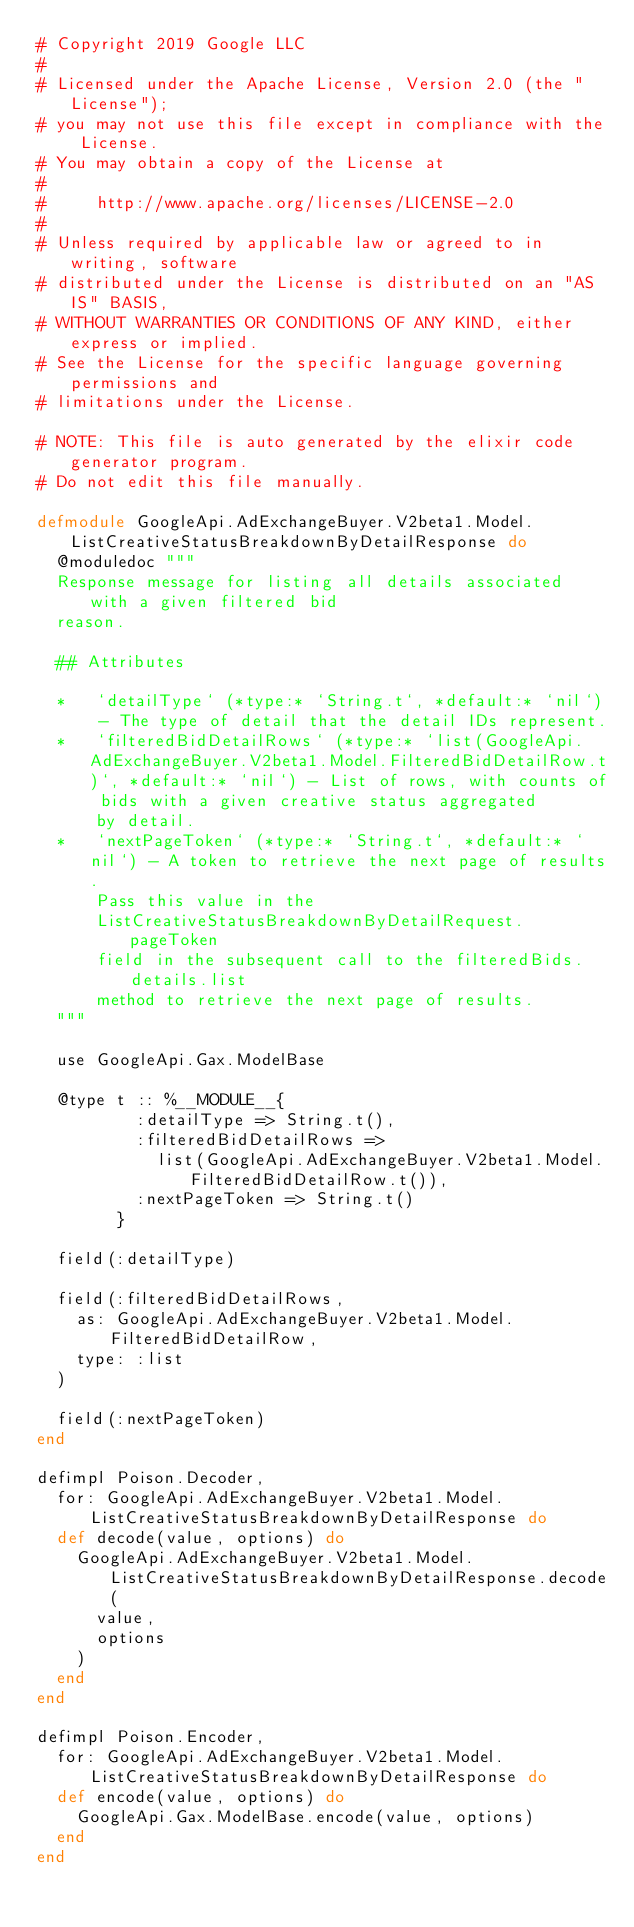<code> <loc_0><loc_0><loc_500><loc_500><_Elixir_># Copyright 2019 Google LLC
#
# Licensed under the Apache License, Version 2.0 (the "License");
# you may not use this file except in compliance with the License.
# You may obtain a copy of the License at
#
#     http://www.apache.org/licenses/LICENSE-2.0
#
# Unless required by applicable law or agreed to in writing, software
# distributed under the License is distributed on an "AS IS" BASIS,
# WITHOUT WARRANTIES OR CONDITIONS OF ANY KIND, either express or implied.
# See the License for the specific language governing permissions and
# limitations under the License.

# NOTE: This file is auto generated by the elixir code generator program.
# Do not edit this file manually.

defmodule GoogleApi.AdExchangeBuyer.V2beta1.Model.ListCreativeStatusBreakdownByDetailResponse do
  @moduledoc """
  Response message for listing all details associated with a given filtered bid
  reason.

  ## Attributes

  *   `detailType` (*type:* `String.t`, *default:* `nil`) - The type of detail that the detail IDs represent.
  *   `filteredBidDetailRows` (*type:* `list(GoogleApi.AdExchangeBuyer.V2beta1.Model.FilteredBidDetailRow.t)`, *default:* `nil`) - List of rows, with counts of bids with a given creative status aggregated
      by detail.
  *   `nextPageToken` (*type:* `String.t`, *default:* `nil`) - A token to retrieve the next page of results.
      Pass this value in the
      ListCreativeStatusBreakdownByDetailRequest.pageToken
      field in the subsequent call to the filteredBids.details.list
      method to retrieve the next page of results.
  """

  use GoogleApi.Gax.ModelBase

  @type t :: %__MODULE__{
          :detailType => String.t(),
          :filteredBidDetailRows =>
            list(GoogleApi.AdExchangeBuyer.V2beta1.Model.FilteredBidDetailRow.t()),
          :nextPageToken => String.t()
        }

  field(:detailType)

  field(:filteredBidDetailRows,
    as: GoogleApi.AdExchangeBuyer.V2beta1.Model.FilteredBidDetailRow,
    type: :list
  )

  field(:nextPageToken)
end

defimpl Poison.Decoder,
  for: GoogleApi.AdExchangeBuyer.V2beta1.Model.ListCreativeStatusBreakdownByDetailResponse do
  def decode(value, options) do
    GoogleApi.AdExchangeBuyer.V2beta1.Model.ListCreativeStatusBreakdownByDetailResponse.decode(
      value,
      options
    )
  end
end

defimpl Poison.Encoder,
  for: GoogleApi.AdExchangeBuyer.V2beta1.Model.ListCreativeStatusBreakdownByDetailResponse do
  def encode(value, options) do
    GoogleApi.Gax.ModelBase.encode(value, options)
  end
end
</code> 